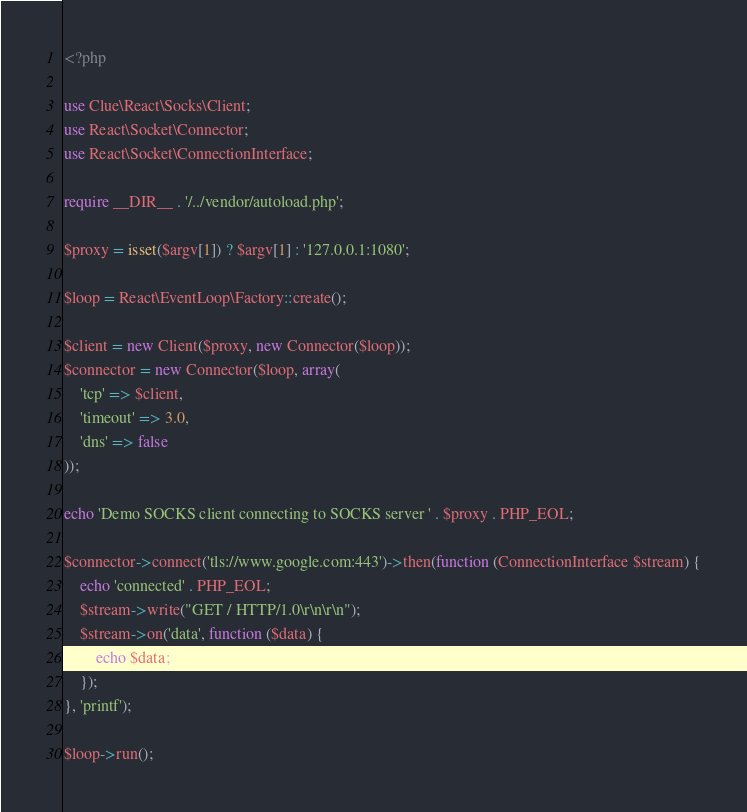<code> <loc_0><loc_0><loc_500><loc_500><_PHP_><?php

use Clue\React\Socks\Client;
use React\Socket\Connector;
use React\Socket\ConnectionInterface;

require __DIR__ . '/../vendor/autoload.php';

$proxy = isset($argv[1]) ? $argv[1] : '127.0.0.1:1080';

$loop = React\EventLoop\Factory::create();

$client = new Client($proxy, new Connector($loop));
$connector = new Connector($loop, array(
    'tcp' => $client,
    'timeout' => 3.0,
    'dns' => false
));

echo 'Demo SOCKS client connecting to SOCKS server ' . $proxy . PHP_EOL;

$connector->connect('tls://www.google.com:443')->then(function (ConnectionInterface $stream) {
    echo 'connected' . PHP_EOL;
    $stream->write("GET / HTTP/1.0\r\n\r\n");
    $stream->on('data', function ($data) {
        echo $data;
    });
}, 'printf');

$loop->run();
</code> 